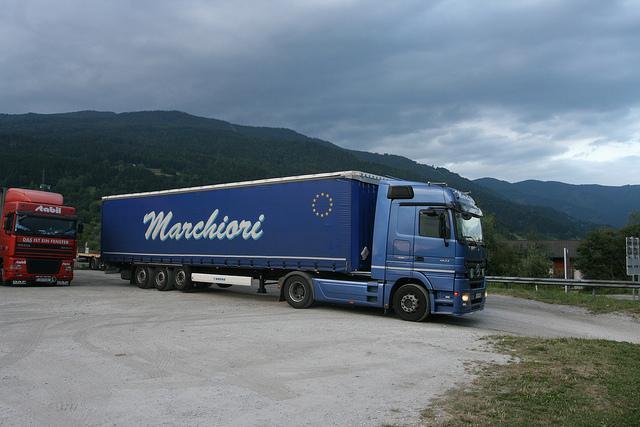How many trucks can you see?
Give a very brief answer. 2. How many trucks are visible?
Give a very brief answer. 2. 